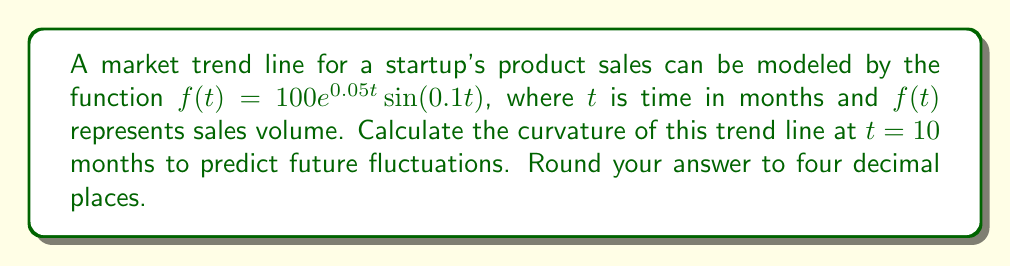Could you help me with this problem? To calculate the curvature of the market trend line, we'll use the formula for curvature of a function:

$$\kappa(t) = \frac{|f''(t)|}{(1 + [f'(t)]^2)^{3/2}}$$

Step 1: Calculate $f'(t)$
$$f'(t) = 100e^{0.05t}(0.05\sin(0.1t) + 0.1\cos(0.1t))$$

Step 2: Calculate $f''(t)$
$$f''(t) = 100e^{0.05t}((0.05^2)\sin(0.1t) + 2(0.05)(0.1)\cos(0.1t) - (0.1^2)\sin(0.1t))$$
$$f''(t) = 100e^{0.05t}(0.0025\sin(0.1t) + 0.01\cos(0.1t) - 0.01\sin(0.1t))$$
$$f''(t) = 100e^{0.05t}(-0.0075\sin(0.1t) + 0.01\cos(0.1t))$$

Step 3: Evaluate $f'(10)$ and $f''(10)$
$$f'(10) = 100e^{0.5}(0.05\sin(1) + 0.1\cos(1)) \approx 85.9204$$
$$f''(10) = 100e^{0.5}(-0.0075\sin(1) + 0.01\cos(1)) \approx 15.8094$$

Step 4: Apply the curvature formula
$$\kappa(10) = \frac{|15.8094|}{(1 + [85.9204]^2)^{3/2}} \approx 0.0021$$

Therefore, the curvature of the market trend line at $t = 10$ months is approximately 0.0021.
Answer: $0.0021$ 